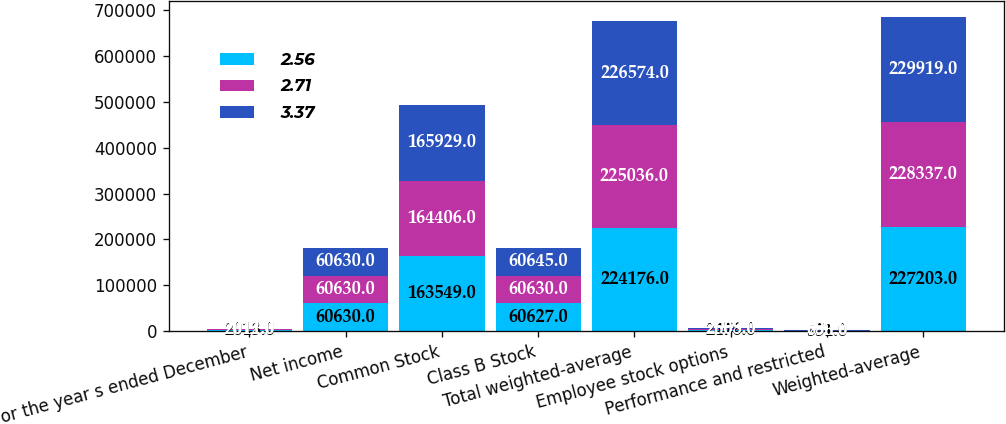Convert chart. <chart><loc_0><loc_0><loc_500><loc_500><stacked_bar_chart><ecel><fcel>For the year s ended December<fcel>Net income<fcel>Common Stock<fcel>Class B Stock<fcel>Total weighted-average<fcel>Employee stock options<fcel>Performance and restricted<fcel>Weighted-average<nl><fcel>2.56<fcel>2013<fcel>60630<fcel>163549<fcel>60627<fcel>224176<fcel>2476<fcel>551<fcel>227203<nl><fcel>2.71<fcel>2012<fcel>60630<fcel>164406<fcel>60630<fcel>225036<fcel>2608<fcel>693<fcel>228337<nl><fcel>3.37<fcel>2011<fcel>60630<fcel>165929<fcel>60645<fcel>226574<fcel>2565<fcel>780<fcel>229919<nl></chart> 